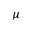Convert formula to latex. <formula><loc_0><loc_0><loc_500><loc_500>\mu</formula> 